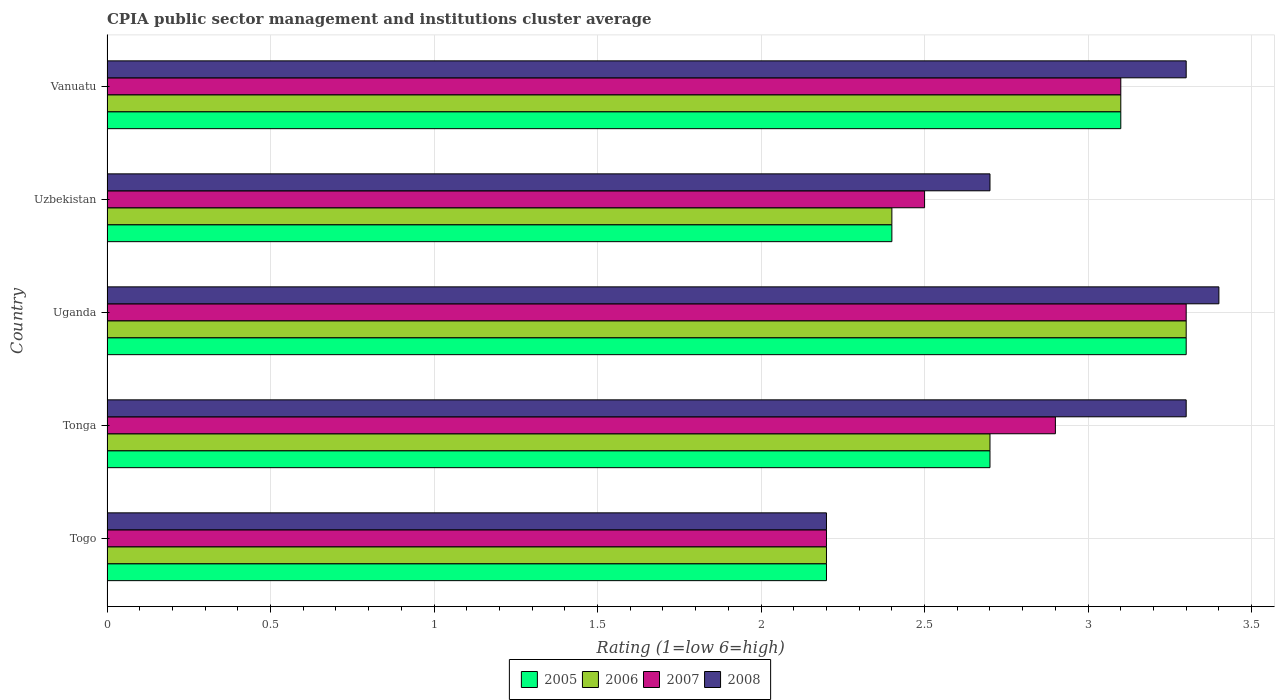How many groups of bars are there?
Provide a succinct answer. 5. Are the number of bars on each tick of the Y-axis equal?
Offer a terse response. Yes. How many bars are there on the 2nd tick from the bottom?
Offer a terse response. 4. What is the label of the 3rd group of bars from the top?
Give a very brief answer. Uganda. In how many cases, is the number of bars for a given country not equal to the number of legend labels?
Keep it short and to the point. 0. Across all countries, what is the minimum CPIA rating in 2006?
Give a very brief answer. 2.2. In which country was the CPIA rating in 2005 maximum?
Your response must be concise. Uganda. In which country was the CPIA rating in 2008 minimum?
Your answer should be compact. Togo. What is the total CPIA rating in 2008 in the graph?
Your answer should be compact. 14.9. What is the difference between the CPIA rating in 2007 in Uzbekistan and that in Vanuatu?
Give a very brief answer. -0.6. What is the average CPIA rating in 2008 per country?
Your answer should be very brief. 2.98. What is the difference between the CPIA rating in 2005 and CPIA rating in 2007 in Uganda?
Provide a short and direct response. 0. In how many countries, is the CPIA rating in 2007 greater than 0.8 ?
Provide a succinct answer. 5. What is the ratio of the CPIA rating in 2006 in Uganda to that in Uzbekistan?
Make the answer very short. 1.38. What is the difference between the highest and the second highest CPIA rating in 2006?
Your answer should be very brief. 0.2. What is the difference between the highest and the lowest CPIA rating in 2005?
Your answer should be very brief. 1.1. Is the sum of the CPIA rating in 2006 in Togo and Tonga greater than the maximum CPIA rating in 2008 across all countries?
Provide a short and direct response. Yes. What is the difference between two consecutive major ticks on the X-axis?
Provide a short and direct response. 0.5. Does the graph contain grids?
Make the answer very short. Yes. How many legend labels are there?
Ensure brevity in your answer.  4. What is the title of the graph?
Provide a succinct answer. CPIA public sector management and institutions cluster average. Does "2009" appear as one of the legend labels in the graph?
Offer a very short reply. No. What is the label or title of the X-axis?
Your answer should be compact. Rating (1=low 6=high). What is the Rating (1=low 6=high) of 2007 in Togo?
Ensure brevity in your answer.  2.2. What is the Rating (1=low 6=high) of 2008 in Togo?
Your response must be concise. 2.2. What is the Rating (1=low 6=high) in 2006 in Tonga?
Provide a short and direct response. 2.7. What is the Rating (1=low 6=high) in 2008 in Tonga?
Keep it short and to the point. 3.3. What is the Rating (1=low 6=high) of 2005 in Uganda?
Your answer should be very brief. 3.3. What is the Rating (1=low 6=high) in 2007 in Uganda?
Offer a terse response. 3.3. What is the Rating (1=low 6=high) of 2008 in Uganda?
Provide a short and direct response. 3.4. What is the Rating (1=low 6=high) of 2007 in Uzbekistan?
Keep it short and to the point. 2.5. What is the Rating (1=low 6=high) in 2008 in Vanuatu?
Make the answer very short. 3.3. Across all countries, what is the maximum Rating (1=low 6=high) in 2005?
Give a very brief answer. 3.3. Across all countries, what is the maximum Rating (1=low 6=high) of 2006?
Provide a short and direct response. 3.3. Across all countries, what is the maximum Rating (1=low 6=high) of 2007?
Ensure brevity in your answer.  3.3. Across all countries, what is the minimum Rating (1=low 6=high) in 2005?
Give a very brief answer. 2.2. Across all countries, what is the minimum Rating (1=low 6=high) of 2007?
Provide a short and direct response. 2.2. What is the total Rating (1=low 6=high) in 2006 in the graph?
Give a very brief answer. 13.7. What is the difference between the Rating (1=low 6=high) in 2008 in Togo and that in Tonga?
Keep it short and to the point. -1.1. What is the difference between the Rating (1=low 6=high) of 2006 in Togo and that in Uganda?
Provide a succinct answer. -1.1. What is the difference between the Rating (1=low 6=high) of 2007 in Togo and that in Uganda?
Provide a short and direct response. -1.1. What is the difference between the Rating (1=low 6=high) in 2008 in Togo and that in Uganda?
Provide a short and direct response. -1.2. What is the difference between the Rating (1=low 6=high) in 2006 in Togo and that in Uzbekistan?
Provide a short and direct response. -0.2. What is the difference between the Rating (1=low 6=high) in 2007 in Togo and that in Uzbekistan?
Your answer should be very brief. -0.3. What is the difference between the Rating (1=low 6=high) in 2008 in Togo and that in Uzbekistan?
Provide a short and direct response. -0.5. What is the difference between the Rating (1=low 6=high) of 2006 in Togo and that in Vanuatu?
Offer a very short reply. -0.9. What is the difference between the Rating (1=low 6=high) of 2007 in Togo and that in Vanuatu?
Keep it short and to the point. -0.9. What is the difference between the Rating (1=low 6=high) in 2008 in Togo and that in Vanuatu?
Keep it short and to the point. -1.1. What is the difference between the Rating (1=low 6=high) of 2005 in Tonga and that in Uganda?
Offer a very short reply. -0.6. What is the difference between the Rating (1=low 6=high) in 2008 in Tonga and that in Uganda?
Offer a terse response. -0.1. What is the difference between the Rating (1=low 6=high) of 2005 in Tonga and that in Uzbekistan?
Offer a terse response. 0.3. What is the difference between the Rating (1=low 6=high) in 2008 in Tonga and that in Uzbekistan?
Your response must be concise. 0.6. What is the difference between the Rating (1=low 6=high) of 2005 in Tonga and that in Vanuatu?
Offer a terse response. -0.4. What is the difference between the Rating (1=low 6=high) of 2006 in Tonga and that in Vanuatu?
Offer a terse response. -0.4. What is the difference between the Rating (1=low 6=high) in 2005 in Uganda and that in Uzbekistan?
Make the answer very short. 0.9. What is the difference between the Rating (1=low 6=high) in 2007 in Uganda and that in Uzbekistan?
Offer a terse response. 0.8. What is the difference between the Rating (1=low 6=high) of 2005 in Uganda and that in Vanuatu?
Ensure brevity in your answer.  0.2. What is the difference between the Rating (1=low 6=high) of 2008 in Uganda and that in Vanuatu?
Offer a very short reply. 0.1. What is the difference between the Rating (1=low 6=high) of 2005 in Uzbekistan and that in Vanuatu?
Provide a succinct answer. -0.7. What is the difference between the Rating (1=low 6=high) of 2007 in Uzbekistan and that in Vanuatu?
Your answer should be compact. -0.6. What is the difference between the Rating (1=low 6=high) in 2008 in Uzbekistan and that in Vanuatu?
Give a very brief answer. -0.6. What is the difference between the Rating (1=low 6=high) in 2005 in Togo and the Rating (1=low 6=high) in 2007 in Tonga?
Offer a very short reply. -0.7. What is the difference between the Rating (1=low 6=high) in 2006 in Togo and the Rating (1=low 6=high) in 2008 in Tonga?
Ensure brevity in your answer.  -1.1. What is the difference between the Rating (1=low 6=high) of 2005 in Togo and the Rating (1=low 6=high) of 2007 in Uganda?
Your answer should be very brief. -1.1. What is the difference between the Rating (1=low 6=high) of 2006 in Togo and the Rating (1=low 6=high) of 2007 in Uganda?
Your answer should be compact. -1.1. What is the difference between the Rating (1=low 6=high) of 2007 in Togo and the Rating (1=low 6=high) of 2008 in Uganda?
Your answer should be very brief. -1.2. What is the difference between the Rating (1=low 6=high) in 2005 in Togo and the Rating (1=low 6=high) in 2006 in Uzbekistan?
Keep it short and to the point. -0.2. What is the difference between the Rating (1=low 6=high) of 2005 in Togo and the Rating (1=low 6=high) of 2007 in Uzbekistan?
Offer a very short reply. -0.3. What is the difference between the Rating (1=low 6=high) in 2006 in Togo and the Rating (1=low 6=high) in 2008 in Uzbekistan?
Provide a short and direct response. -0.5. What is the difference between the Rating (1=low 6=high) of 2007 in Togo and the Rating (1=low 6=high) of 2008 in Uzbekistan?
Ensure brevity in your answer.  -0.5. What is the difference between the Rating (1=low 6=high) of 2005 in Togo and the Rating (1=low 6=high) of 2007 in Vanuatu?
Ensure brevity in your answer.  -0.9. What is the difference between the Rating (1=low 6=high) of 2006 in Togo and the Rating (1=low 6=high) of 2007 in Vanuatu?
Your answer should be compact. -0.9. What is the difference between the Rating (1=low 6=high) in 2006 in Togo and the Rating (1=low 6=high) in 2008 in Vanuatu?
Your answer should be very brief. -1.1. What is the difference between the Rating (1=low 6=high) of 2007 in Togo and the Rating (1=low 6=high) of 2008 in Vanuatu?
Keep it short and to the point. -1.1. What is the difference between the Rating (1=low 6=high) in 2006 in Tonga and the Rating (1=low 6=high) in 2007 in Uganda?
Provide a succinct answer. -0.6. What is the difference between the Rating (1=low 6=high) of 2006 in Tonga and the Rating (1=low 6=high) of 2008 in Uganda?
Provide a short and direct response. -0.7. What is the difference between the Rating (1=low 6=high) of 2007 in Tonga and the Rating (1=low 6=high) of 2008 in Uganda?
Provide a short and direct response. -0.5. What is the difference between the Rating (1=low 6=high) in 2006 in Tonga and the Rating (1=low 6=high) in 2008 in Uzbekistan?
Make the answer very short. 0. What is the difference between the Rating (1=low 6=high) in 2007 in Tonga and the Rating (1=low 6=high) in 2008 in Uzbekistan?
Provide a succinct answer. 0.2. What is the difference between the Rating (1=low 6=high) of 2006 in Tonga and the Rating (1=low 6=high) of 2007 in Vanuatu?
Provide a short and direct response. -0.4. What is the difference between the Rating (1=low 6=high) of 2006 in Tonga and the Rating (1=low 6=high) of 2008 in Vanuatu?
Keep it short and to the point. -0.6. What is the difference between the Rating (1=low 6=high) of 2007 in Tonga and the Rating (1=low 6=high) of 2008 in Vanuatu?
Give a very brief answer. -0.4. What is the difference between the Rating (1=low 6=high) in 2005 in Uganda and the Rating (1=low 6=high) in 2007 in Uzbekistan?
Provide a succinct answer. 0.8. What is the difference between the Rating (1=low 6=high) of 2006 in Uganda and the Rating (1=low 6=high) of 2007 in Uzbekistan?
Ensure brevity in your answer.  0.8. What is the difference between the Rating (1=low 6=high) in 2006 in Uganda and the Rating (1=low 6=high) in 2008 in Uzbekistan?
Your answer should be very brief. 0.6. What is the difference between the Rating (1=low 6=high) in 2005 in Uganda and the Rating (1=low 6=high) in 2006 in Vanuatu?
Your answer should be very brief. 0.2. What is the difference between the Rating (1=low 6=high) in 2006 in Uganda and the Rating (1=low 6=high) in 2007 in Vanuatu?
Keep it short and to the point. 0.2. What is the difference between the Rating (1=low 6=high) of 2006 in Uganda and the Rating (1=low 6=high) of 2008 in Vanuatu?
Provide a short and direct response. 0. What is the difference between the Rating (1=low 6=high) in 2005 in Uzbekistan and the Rating (1=low 6=high) in 2006 in Vanuatu?
Keep it short and to the point. -0.7. What is the difference between the Rating (1=low 6=high) in 2005 in Uzbekistan and the Rating (1=low 6=high) in 2008 in Vanuatu?
Your answer should be compact. -0.9. What is the difference between the Rating (1=low 6=high) in 2006 in Uzbekistan and the Rating (1=low 6=high) in 2008 in Vanuatu?
Give a very brief answer. -0.9. What is the difference between the Rating (1=low 6=high) of 2007 in Uzbekistan and the Rating (1=low 6=high) of 2008 in Vanuatu?
Give a very brief answer. -0.8. What is the average Rating (1=low 6=high) in 2005 per country?
Your response must be concise. 2.74. What is the average Rating (1=low 6=high) in 2006 per country?
Ensure brevity in your answer.  2.74. What is the average Rating (1=low 6=high) of 2007 per country?
Ensure brevity in your answer.  2.8. What is the average Rating (1=low 6=high) of 2008 per country?
Provide a short and direct response. 2.98. What is the difference between the Rating (1=low 6=high) of 2005 and Rating (1=low 6=high) of 2006 in Togo?
Provide a succinct answer. 0. What is the difference between the Rating (1=low 6=high) in 2005 and Rating (1=low 6=high) in 2007 in Togo?
Offer a very short reply. 0. What is the difference between the Rating (1=low 6=high) in 2005 and Rating (1=low 6=high) in 2008 in Togo?
Your response must be concise. 0. What is the difference between the Rating (1=low 6=high) of 2006 and Rating (1=low 6=high) of 2007 in Togo?
Your response must be concise. 0. What is the difference between the Rating (1=low 6=high) of 2005 and Rating (1=low 6=high) of 2006 in Tonga?
Provide a succinct answer. 0. What is the difference between the Rating (1=low 6=high) in 2005 and Rating (1=low 6=high) in 2007 in Tonga?
Keep it short and to the point. -0.2. What is the difference between the Rating (1=low 6=high) in 2007 and Rating (1=low 6=high) in 2008 in Tonga?
Your response must be concise. -0.4. What is the difference between the Rating (1=low 6=high) in 2006 and Rating (1=low 6=high) in 2008 in Uganda?
Your answer should be very brief. -0.1. What is the difference between the Rating (1=low 6=high) in 2007 and Rating (1=low 6=high) in 2008 in Uganda?
Your response must be concise. -0.1. What is the difference between the Rating (1=low 6=high) in 2006 and Rating (1=low 6=high) in 2007 in Uzbekistan?
Your response must be concise. -0.1. What is the difference between the Rating (1=low 6=high) of 2007 and Rating (1=low 6=high) of 2008 in Uzbekistan?
Provide a short and direct response. -0.2. What is the difference between the Rating (1=low 6=high) in 2005 and Rating (1=low 6=high) in 2006 in Vanuatu?
Your answer should be compact. 0. What is the difference between the Rating (1=low 6=high) of 2006 and Rating (1=low 6=high) of 2007 in Vanuatu?
Offer a terse response. 0. What is the difference between the Rating (1=low 6=high) of 2006 and Rating (1=low 6=high) of 2008 in Vanuatu?
Offer a terse response. -0.2. What is the ratio of the Rating (1=low 6=high) in 2005 in Togo to that in Tonga?
Provide a short and direct response. 0.81. What is the ratio of the Rating (1=low 6=high) in 2006 in Togo to that in Tonga?
Keep it short and to the point. 0.81. What is the ratio of the Rating (1=low 6=high) in 2007 in Togo to that in Tonga?
Your answer should be compact. 0.76. What is the ratio of the Rating (1=low 6=high) of 2007 in Togo to that in Uganda?
Your answer should be very brief. 0.67. What is the ratio of the Rating (1=low 6=high) in 2008 in Togo to that in Uganda?
Your answer should be very brief. 0.65. What is the ratio of the Rating (1=low 6=high) in 2005 in Togo to that in Uzbekistan?
Offer a terse response. 0.92. What is the ratio of the Rating (1=low 6=high) of 2007 in Togo to that in Uzbekistan?
Your response must be concise. 0.88. What is the ratio of the Rating (1=low 6=high) in 2008 in Togo to that in Uzbekistan?
Your answer should be very brief. 0.81. What is the ratio of the Rating (1=low 6=high) in 2005 in Togo to that in Vanuatu?
Give a very brief answer. 0.71. What is the ratio of the Rating (1=low 6=high) of 2006 in Togo to that in Vanuatu?
Give a very brief answer. 0.71. What is the ratio of the Rating (1=low 6=high) in 2007 in Togo to that in Vanuatu?
Provide a succinct answer. 0.71. What is the ratio of the Rating (1=low 6=high) of 2005 in Tonga to that in Uganda?
Ensure brevity in your answer.  0.82. What is the ratio of the Rating (1=low 6=high) of 2006 in Tonga to that in Uganda?
Make the answer very short. 0.82. What is the ratio of the Rating (1=low 6=high) of 2007 in Tonga to that in Uganda?
Provide a short and direct response. 0.88. What is the ratio of the Rating (1=low 6=high) of 2008 in Tonga to that in Uganda?
Your answer should be very brief. 0.97. What is the ratio of the Rating (1=low 6=high) in 2005 in Tonga to that in Uzbekistan?
Your response must be concise. 1.12. What is the ratio of the Rating (1=low 6=high) in 2007 in Tonga to that in Uzbekistan?
Your response must be concise. 1.16. What is the ratio of the Rating (1=low 6=high) in 2008 in Tonga to that in Uzbekistan?
Your answer should be compact. 1.22. What is the ratio of the Rating (1=low 6=high) in 2005 in Tonga to that in Vanuatu?
Make the answer very short. 0.87. What is the ratio of the Rating (1=low 6=high) of 2006 in Tonga to that in Vanuatu?
Provide a succinct answer. 0.87. What is the ratio of the Rating (1=low 6=high) in 2007 in Tonga to that in Vanuatu?
Provide a succinct answer. 0.94. What is the ratio of the Rating (1=low 6=high) in 2005 in Uganda to that in Uzbekistan?
Offer a very short reply. 1.38. What is the ratio of the Rating (1=low 6=high) of 2006 in Uganda to that in Uzbekistan?
Offer a very short reply. 1.38. What is the ratio of the Rating (1=low 6=high) of 2007 in Uganda to that in Uzbekistan?
Your answer should be very brief. 1.32. What is the ratio of the Rating (1=low 6=high) in 2008 in Uganda to that in Uzbekistan?
Make the answer very short. 1.26. What is the ratio of the Rating (1=low 6=high) in 2005 in Uganda to that in Vanuatu?
Your answer should be very brief. 1.06. What is the ratio of the Rating (1=low 6=high) in 2006 in Uganda to that in Vanuatu?
Ensure brevity in your answer.  1.06. What is the ratio of the Rating (1=low 6=high) of 2007 in Uganda to that in Vanuatu?
Your answer should be compact. 1.06. What is the ratio of the Rating (1=low 6=high) in 2008 in Uganda to that in Vanuatu?
Give a very brief answer. 1.03. What is the ratio of the Rating (1=low 6=high) in 2005 in Uzbekistan to that in Vanuatu?
Give a very brief answer. 0.77. What is the ratio of the Rating (1=low 6=high) in 2006 in Uzbekistan to that in Vanuatu?
Your answer should be compact. 0.77. What is the ratio of the Rating (1=low 6=high) in 2007 in Uzbekistan to that in Vanuatu?
Offer a terse response. 0.81. What is the ratio of the Rating (1=low 6=high) in 2008 in Uzbekistan to that in Vanuatu?
Provide a succinct answer. 0.82. What is the difference between the highest and the second highest Rating (1=low 6=high) in 2005?
Offer a terse response. 0.2. What is the difference between the highest and the second highest Rating (1=low 6=high) in 2007?
Offer a terse response. 0.2. 